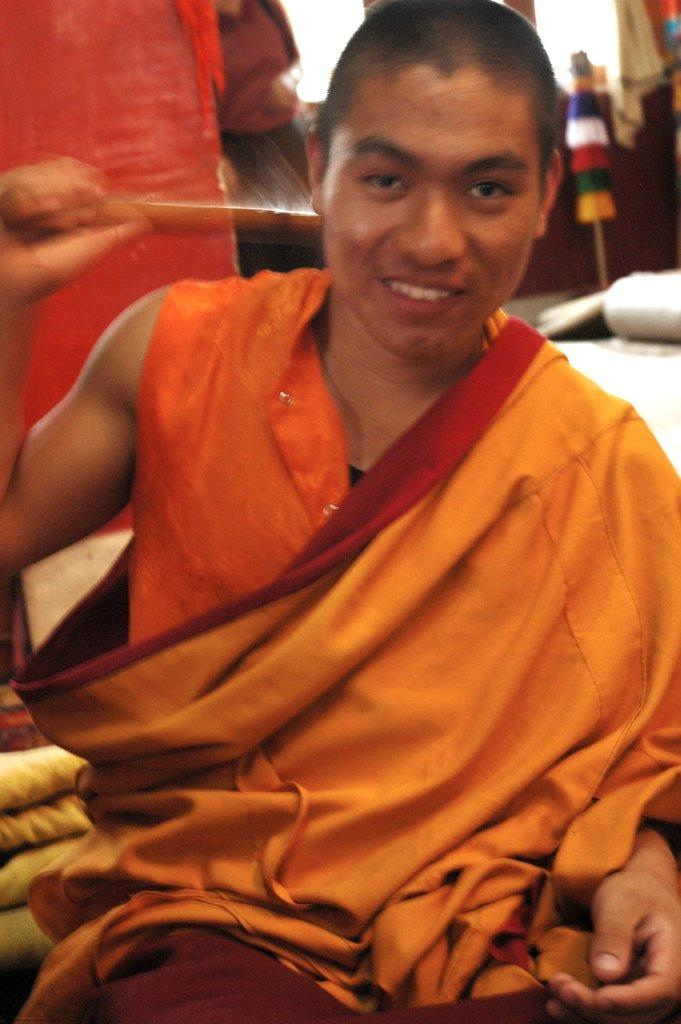What is present in the image? There is a man in the image. Can you describe the background of the man? The background of the man is blurred. What type of root can be seen growing near the man in the image? There is no root visible in the image; the background is blurred, and no roots are mentioned in the facts provided. 